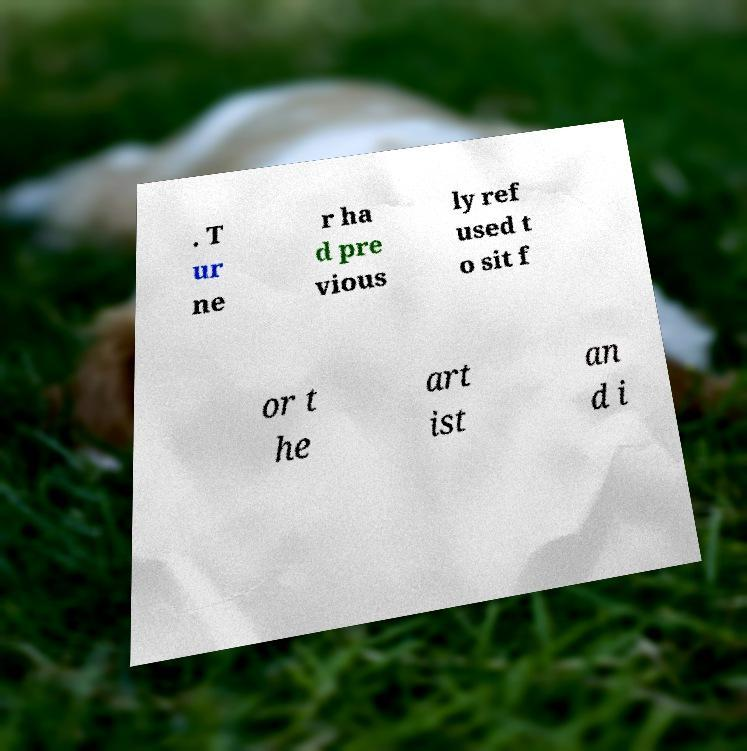Could you extract and type out the text from this image? . T ur ne r ha d pre vious ly ref used t o sit f or t he art ist an d i 